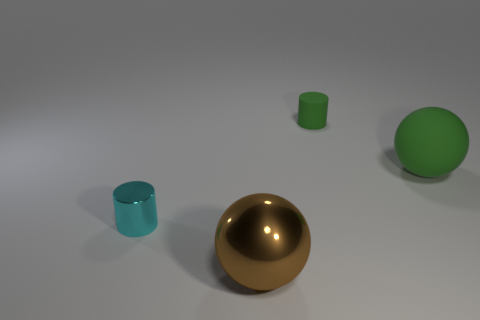What number of large balls are there?
Your answer should be compact. 2. There is a large thing that is behind the shiny cylinder; does it have the same color as the sphere in front of the cyan cylinder?
Your answer should be very brief. No. What size is the cylinder that is the same color as the large matte sphere?
Keep it short and to the point. Small. What number of other objects are there of the same size as the brown metallic ball?
Give a very brief answer. 1. What is the color of the tiny object that is left of the brown metal sphere?
Your response must be concise. Cyan. Does the small cylinder that is on the right side of the big brown object have the same material as the cyan thing?
Make the answer very short. No. What number of things are both to the right of the big brown metallic object and in front of the small green thing?
Your response must be concise. 1. There is a matte thing to the left of the green object that is in front of the small cylinder right of the small cyan shiny cylinder; what is its color?
Your answer should be compact. Green. What number of other things are the same shape as the small cyan object?
Make the answer very short. 1. There is a small cylinder that is on the right side of the large brown metal ball; is there a large ball that is in front of it?
Your response must be concise. Yes. 